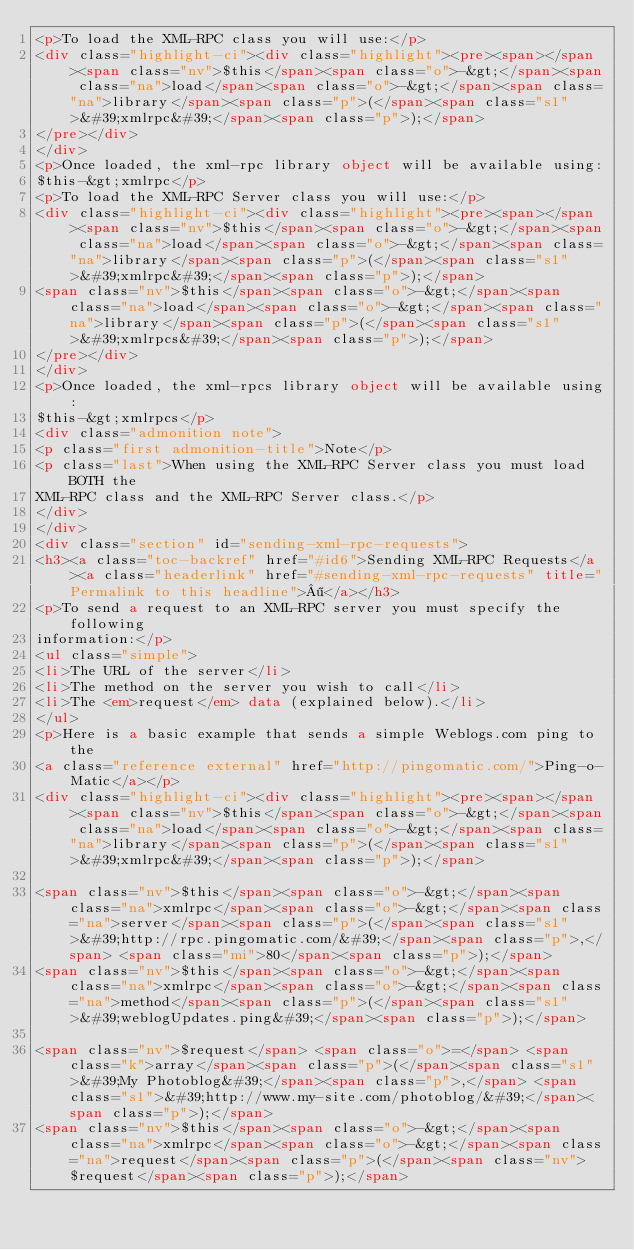Convert code to text. <code><loc_0><loc_0><loc_500><loc_500><_HTML_><p>To load the XML-RPC class you will use:</p>
<div class="highlight-ci"><div class="highlight"><pre><span></span><span class="nv">$this</span><span class="o">-&gt;</span><span class="na">load</span><span class="o">-&gt;</span><span class="na">library</span><span class="p">(</span><span class="s1">&#39;xmlrpc&#39;</span><span class="p">);</span>
</pre></div>
</div>
<p>Once loaded, the xml-rpc library object will be available using:
$this-&gt;xmlrpc</p>
<p>To load the XML-RPC Server class you will use:</p>
<div class="highlight-ci"><div class="highlight"><pre><span></span><span class="nv">$this</span><span class="o">-&gt;</span><span class="na">load</span><span class="o">-&gt;</span><span class="na">library</span><span class="p">(</span><span class="s1">&#39;xmlrpc&#39;</span><span class="p">);</span>
<span class="nv">$this</span><span class="o">-&gt;</span><span class="na">load</span><span class="o">-&gt;</span><span class="na">library</span><span class="p">(</span><span class="s1">&#39;xmlrpcs&#39;</span><span class="p">);</span>
</pre></div>
</div>
<p>Once loaded, the xml-rpcs library object will be available using:
$this-&gt;xmlrpcs</p>
<div class="admonition note">
<p class="first admonition-title">Note</p>
<p class="last">When using the XML-RPC Server class you must load BOTH the
XML-RPC class and the XML-RPC Server class.</p>
</div>
</div>
<div class="section" id="sending-xml-rpc-requests">
<h3><a class="toc-backref" href="#id6">Sending XML-RPC Requests</a><a class="headerlink" href="#sending-xml-rpc-requests" title="Permalink to this headline">¶</a></h3>
<p>To send a request to an XML-RPC server you must specify the following
information:</p>
<ul class="simple">
<li>The URL of the server</li>
<li>The method on the server you wish to call</li>
<li>The <em>request</em> data (explained below).</li>
</ul>
<p>Here is a basic example that sends a simple Weblogs.com ping to the
<a class="reference external" href="http://pingomatic.com/">Ping-o-Matic</a></p>
<div class="highlight-ci"><div class="highlight"><pre><span></span><span class="nv">$this</span><span class="o">-&gt;</span><span class="na">load</span><span class="o">-&gt;</span><span class="na">library</span><span class="p">(</span><span class="s1">&#39;xmlrpc&#39;</span><span class="p">);</span>

<span class="nv">$this</span><span class="o">-&gt;</span><span class="na">xmlrpc</span><span class="o">-&gt;</span><span class="na">server</span><span class="p">(</span><span class="s1">&#39;http://rpc.pingomatic.com/&#39;</span><span class="p">,</span> <span class="mi">80</span><span class="p">);</span>
<span class="nv">$this</span><span class="o">-&gt;</span><span class="na">xmlrpc</span><span class="o">-&gt;</span><span class="na">method</span><span class="p">(</span><span class="s1">&#39;weblogUpdates.ping&#39;</span><span class="p">);</span>

<span class="nv">$request</span> <span class="o">=</span> <span class="k">array</span><span class="p">(</span><span class="s1">&#39;My Photoblog&#39;</span><span class="p">,</span> <span class="s1">&#39;http://www.my-site.com/photoblog/&#39;</span><span class="p">);</span>
<span class="nv">$this</span><span class="o">-&gt;</span><span class="na">xmlrpc</span><span class="o">-&gt;</span><span class="na">request</span><span class="p">(</span><span class="nv">$request</span><span class="p">);</span>
</code> 